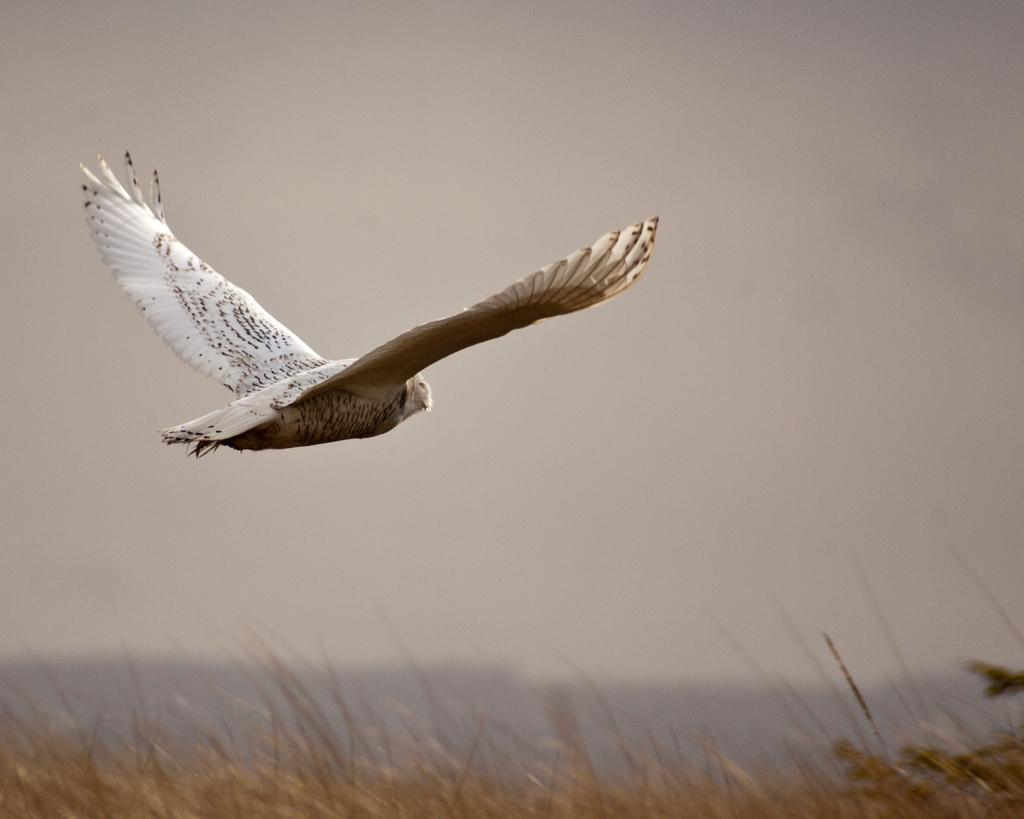What type of animal can be seen in the image? There is a bird in the image. What is the color of the bird? The bird is white in color. What is the bird doing in the image? The bird is flying in the sky. What type of vegetation is visible in the image? There are plants visible in the image. What is the condition of the sky in the image? The sky is clear in the image. Is there a farmer working in the field in the image? There is no farmer or field present in the image; it features a bird flying in the sky with plants and a clear sky. 